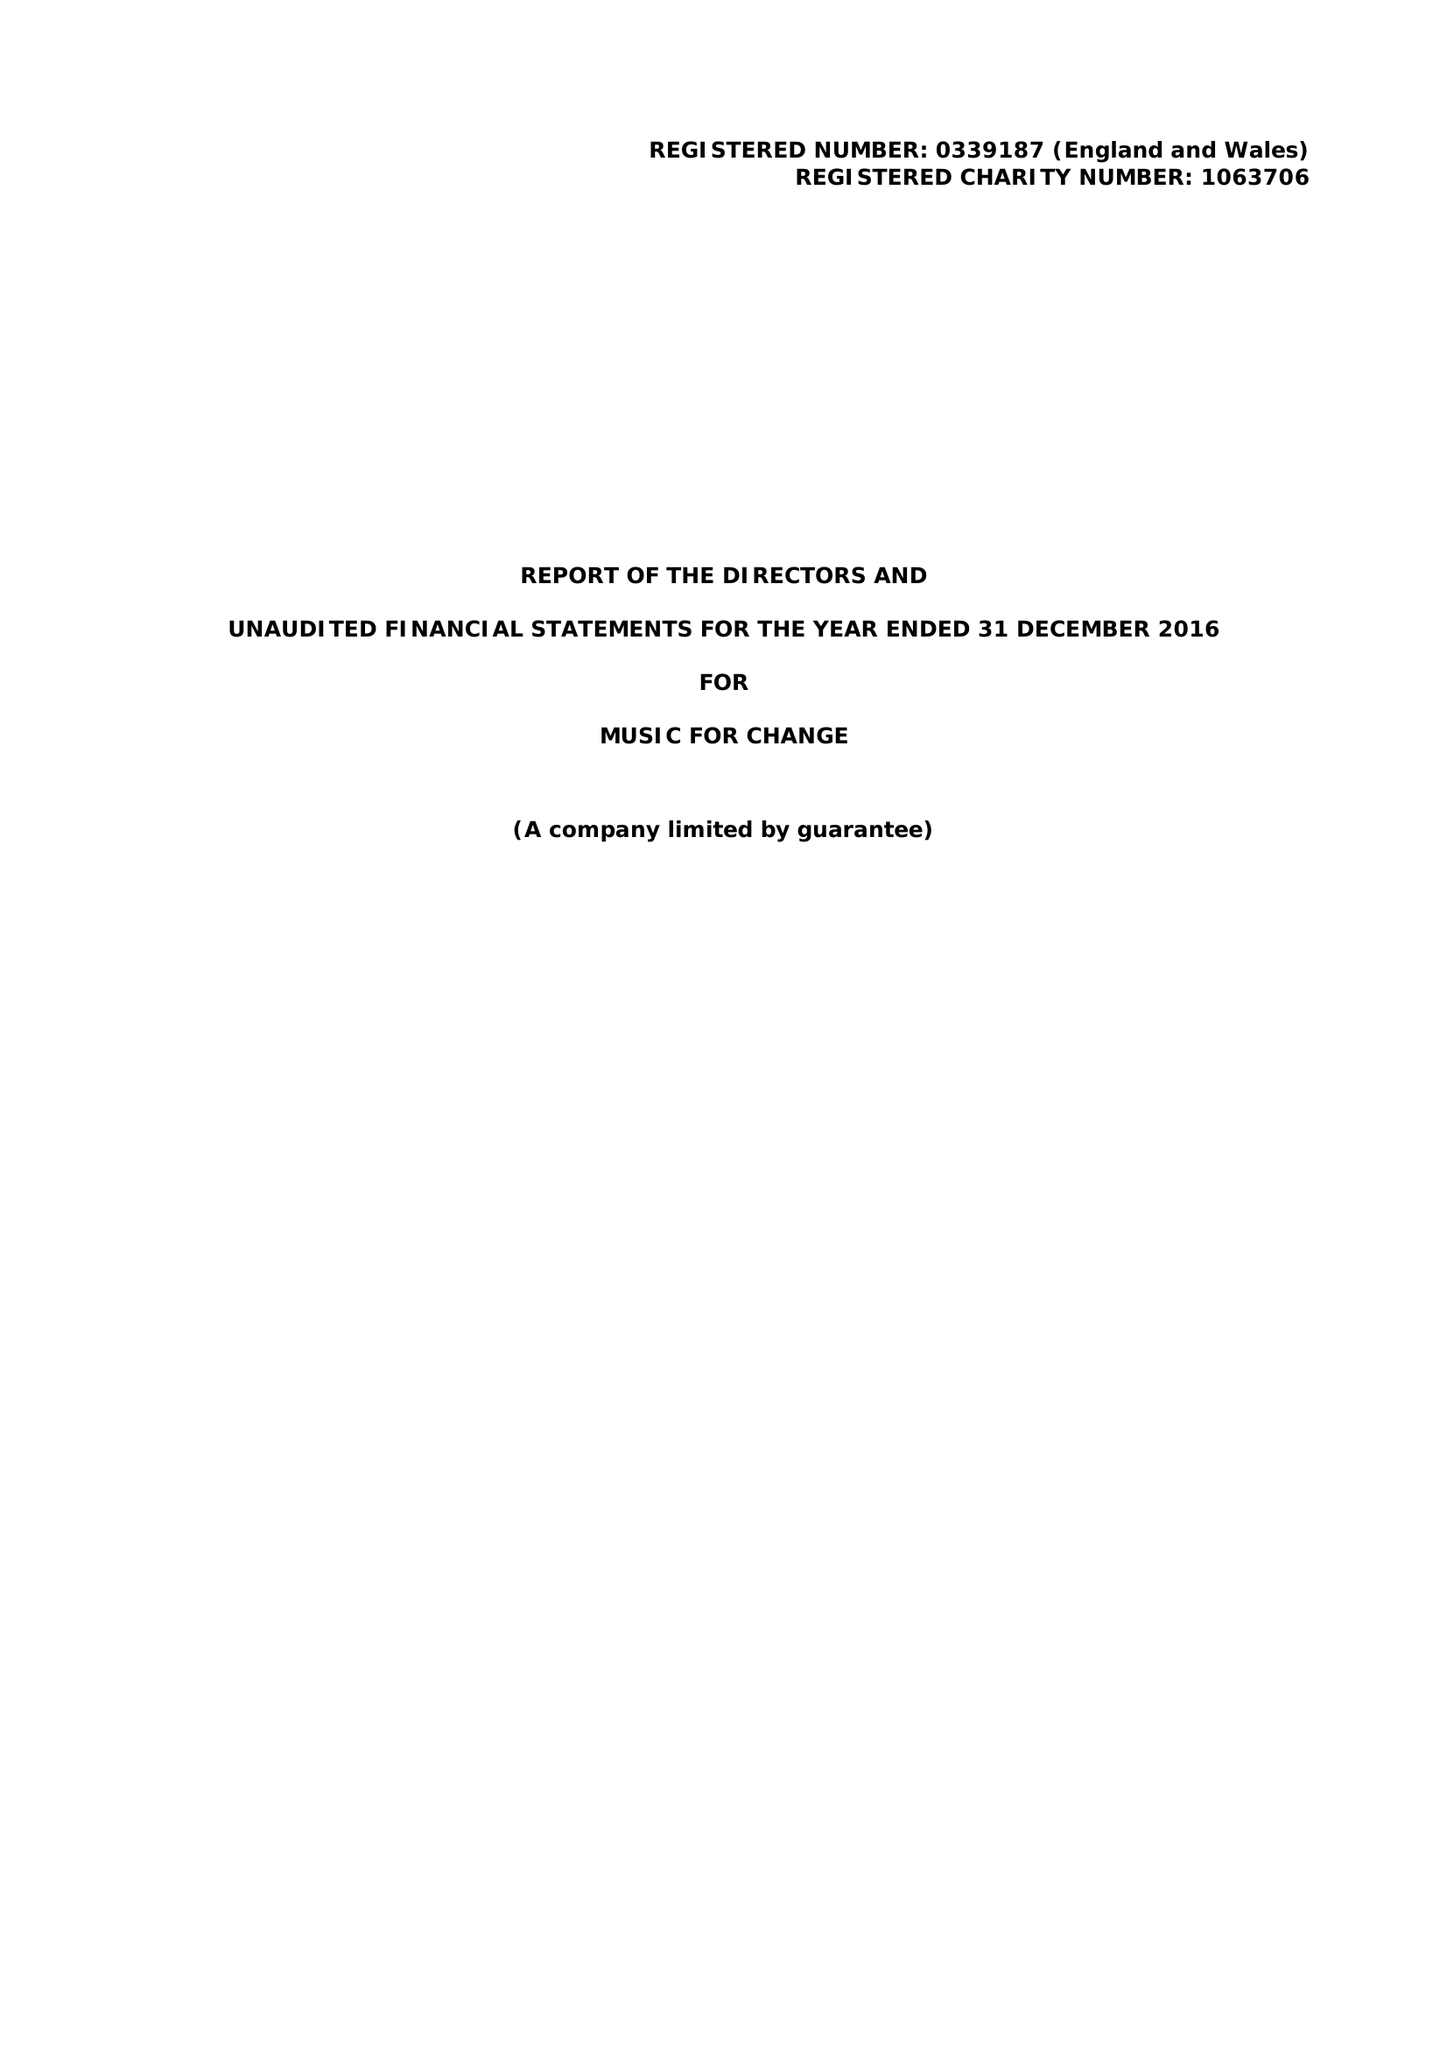What is the value for the address__postcode?
Answer the question using a single word or phrase. CT1 2NR 